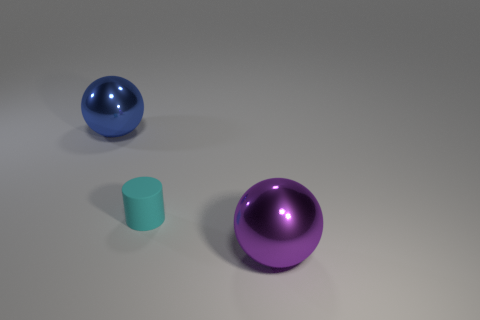Add 1 large gray spheres. How many objects exist? 4 Subtract all cylinders. How many objects are left? 2 Add 3 large blue spheres. How many large blue spheres exist? 4 Subtract 0 gray blocks. How many objects are left? 3 Subtract all large purple metallic objects. Subtract all small purple metallic balls. How many objects are left? 2 Add 3 blue things. How many blue things are left? 4 